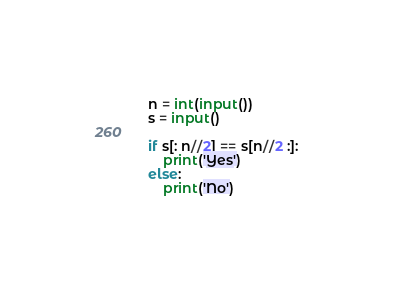<code> <loc_0><loc_0><loc_500><loc_500><_Python_>n = int(input())
s = input()

if s[: n//2] == s[n//2 :]:
    print('Yes')
else:
    print('No')</code> 